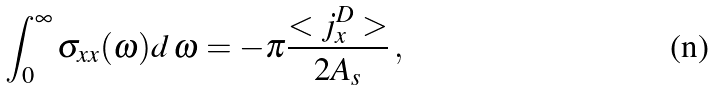Convert formula to latex. <formula><loc_0><loc_0><loc_500><loc_500>\int ^ { \infty } _ { 0 } \sigma _ { x x } ( \omega ) d \, \omega = - \pi \frac { < j ^ { D } _ { x } > } { 2 A _ { s } } \, ,</formula> 